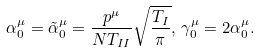<formula> <loc_0><loc_0><loc_500><loc_500>\alpha _ { 0 } ^ { \mu } = \tilde { \alpha } _ { 0 } ^ { \mu } = \frac { p ^ { \mu } } { N T _ { I I } } \sqrt { \frac { T _ { I } } { \pi } } , \, \gamma _ { 0 } ^ { \mu } = 2 \alpha _ { 0 } ^ { \mu } .</formula> 